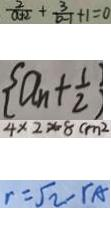<formula> <loc_0><loc_0><loc_500><loc_500>\frac { 2 } { a + 2 } + \frac { 3 } { b - 1 } + 1 = 0 
 \{ a _ { n } + \frac { 1 } { 2 } \} 
 4 \times 2 \times 8 c m ^ { 2 } 
 r = \sqrt { 2 } - r _ { A }</formula> 